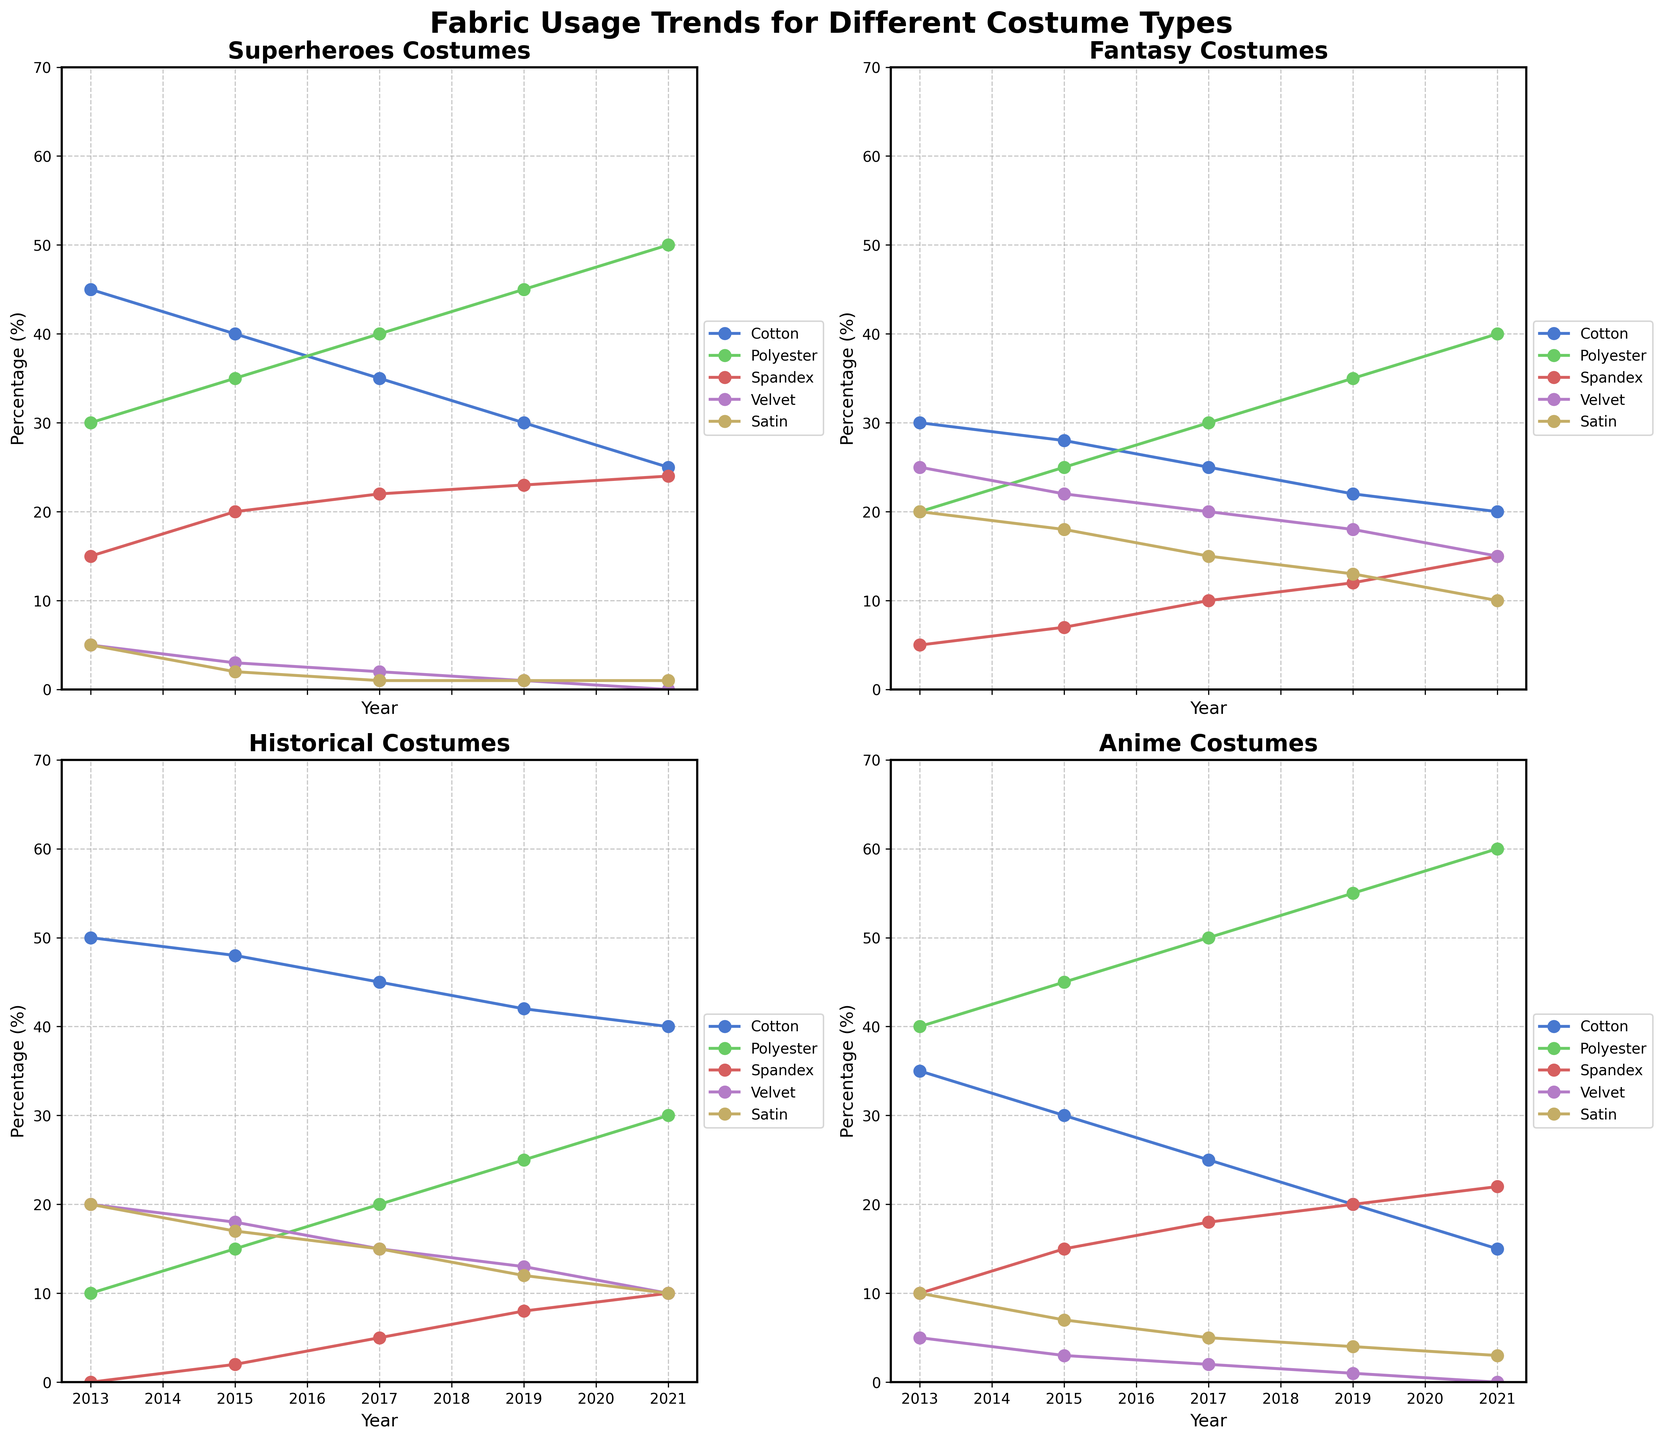What's the title of the plot? The title is usually at the top of the plot, and for this figure, it is "Fabric Usage Trends for Different Costume Types".
Answer: Fabric Usage Trends for Different Costume Types How many subplots are used in the figure? Observe the layout of the figure. There are 2 rows and 2 columns of subplots, making a total of 4 subplots.
Answer: 4 What is the trend for Cotton usage in Superheroes costumes from 2013 to 2021? In the Superheroes subplot, locate the line representing Cotton. The percentage decreases from 45% in 2013 to 25% in 2021.
Answer: Decreasing trend Which fabric showed the most significant increase in usage for Anime costumes over the years? Look at the Anime subplot and compare the lines representing different fabrics from 2013 to 2021. Polyester shows the most significant increase from 40% to 60%.
Answer: Polyester Compare the usage of Spandex in Fantasy and Historical costumes in 2021. Which usage is higher and by how much? Locate the Spandex data points for Fantasy and Historical costumes in 2021. Fantasy has 15% and Historical has 10%. The difference is 15% - 10% = 5%.
Answer: Fantasy by 5% Which costume type had the highest usage of Velvet in 2013? Observe the Velvet data points in the 2013 columns across all subplots. Historical costumes used 20%, which is the highest among the four costume types.
Answer: Historical What are the top 3 most used fabrics in Historical costumes in 2017? Locate the 2017 data points in the Historical subplot. Rank the percentages: Cotton (50%), Velvet (20%), Satin (20%). Since Velvet and Satin are equal, both are included in the top 3.
Answer: Cotton, Velvet, Satin Was there any year where one of the fabrics dropped to 0% usage for any costume type? If so, which one? Scan through each subplot to find any lines that drop to 0%. For Superheroes costumes, Velvet dropped to 0% in 2021.
Answer: Velvet in Superheroes, 2021 Compare the overall trend for Satin in Superheroes and Fantasy costumes. How do they differ? Observe the trends of the Satin lines in both subplots. In Superheroes, Satin decreases slightly to 1% over the years, while in Fantasy, it decreases significantly from 20% to 10%.
Answer: Both decrease, but Fantasy decreases more sharply 